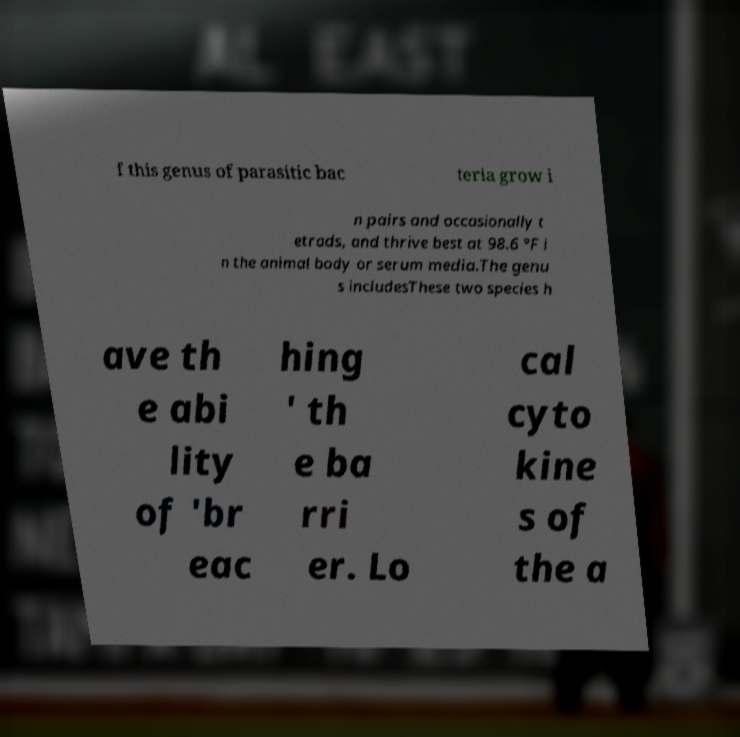Can you accurately transcribe the text from the provided image for me? f this genus of parasitic bac teria grow i n pairs and occasionally t etrads, and thrive best at 98.6 °F i n the animal body or serum media.The genu s includesThese two species h ave th e abi lity of 'br eac hing ' th e ba rri er. Lo cal cyto kine s of the a 